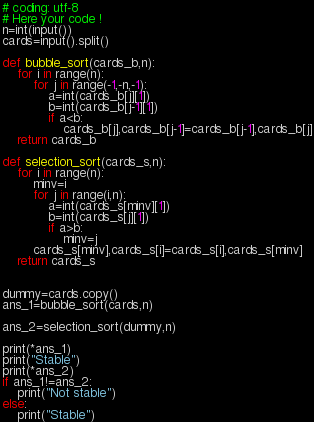Convert code to text. <code><loc_0><loc_0><loc_500><loc_500><_Python_># coding: utf-8
# Here your code !
n=int(input())
cards=input().split()

def bubble_sort(cards_b,n):
    for i in range(n):
        for j in range(-1,-n,-1):
            a=int(cards_b[j][1])
            b=int(cards_b[j-1][1])
            if a<b:
                cards_b[j],cards_b[j-1]=cards_b[j-1],cards_b[j]
    return cards_b

def selection_sort(cards_s,n):
    for i in range(n):
        minv=i
        for j in range(i,n):
            a=int(cards_s[minv][1])
            b=int(cards_s[j][1])
            if a>b:
                minv=j
        cards_s[minv],cards_s[i]=cards_s[i],cards_s[minv]
    return cards_s


dummy=cards.copy()
ans_1=bubble_sort(cards,n)

ans_2=selection_sort(dummy,n)

print(*ans_1)
print("Stable")
print(*ans_2)
if ans_1!=ans_2:
    print("Not stable")
else:
    print("Stable")</code> 